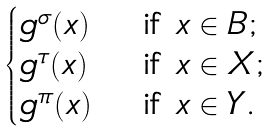<formula> <loc_0><loc_0><loc_500><loc_500>\begin{cases} g ^ { \sigma } ( x ) & \text { if $x\in B$;} \\ g ^ { \tau } ( x ) & \text { if $x\in X$;} \\ g ^ { \pi } ( x ) & \text { if $x\in Y$.} \end{cases}</formula> 